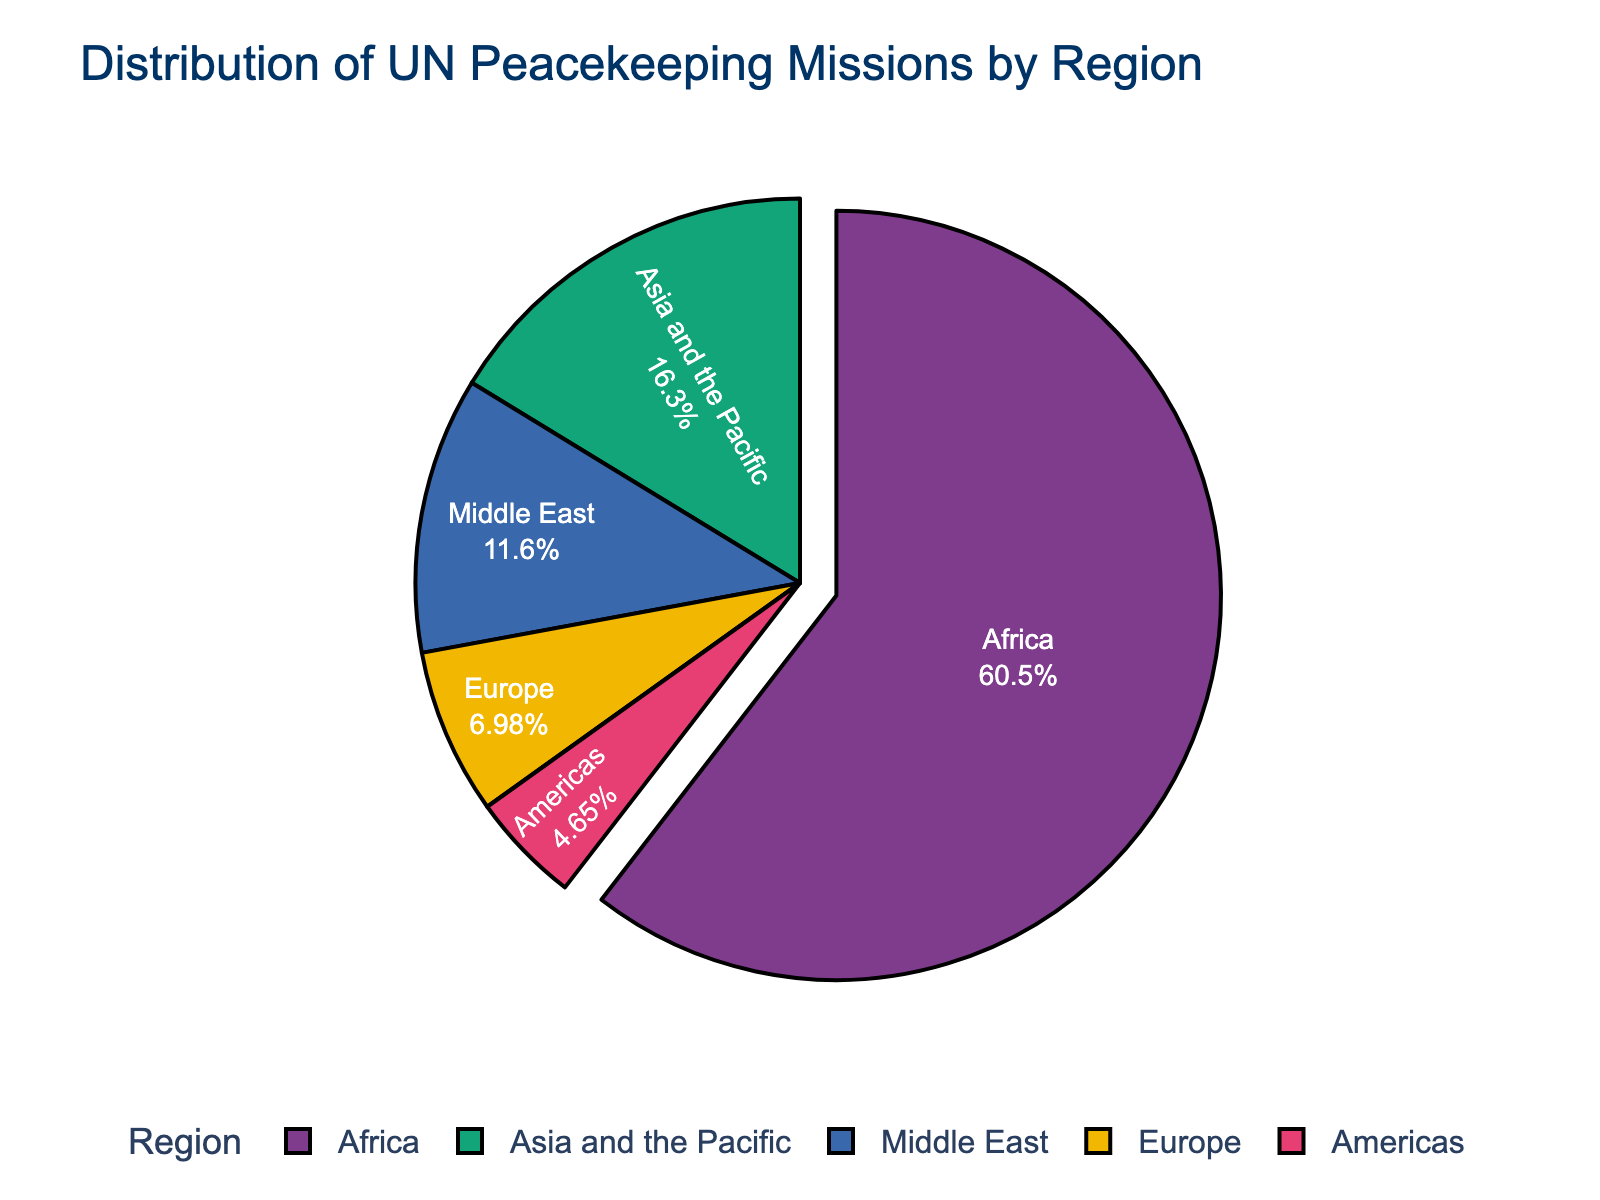Which region has the highest number of UN peacekeeping missions? Based on the largest portion of the pie chart, we can see that Africa has the highest number of missions.
Answer: Africa Which region has the fewest UN peacekeeping missions? The smallest segment of the pie chart is for the Americas, indicating it has the fewest missions.
Answer: Americas What percentage of UN peacekeeping missions are in Africa? Looking at the segment labeled "Africa", we see the percentage is marked inside the segment.
Answer: 55.3% How many more missions are there in Africa compared to Europe? Africa has 26 missions and Europe has 3, the difference is calculated as 26 - 3.
Answer: 23 Are there more missions in the Middle East or in Asia and the Pacific? Comparing the sizes of the segments for the Middle East and Asia and the Pacific, we see Asia and the Pacific has more missions (7 vs. 5).
Answer: Asia and the Pacific Which regions combined account for more than half of the UN peacekeeping missions? Adding the missions from Africa (26) and any other region whose combined total results in more than half: Africa (26) + Asia and the Pacific (7) = 33 (which is more than half of 43, the total number of missions).
Answer: Africa and Asia and the Pacific What is the total number of UN peacekeeping missions in regions outside Africa? Adding the missions for Asia and the Pacific (7), Europe (3), Middle East (5), and Americas (2) results in 17.
Answer: 17 If each region's mission percentage correlates directly to the geographic size, which region would be the largest? Since Africa has the highest percentage of missions (55.3%), it would be the largest region if mission distribution correlates directly with geographic size.
Answer: Africa What is the second-largest region by the number of missions and what percentage of the total does it represent? The second-largest region would be Asia and the Pacific with 7 missions. The percentage can be seen on the pie chart segment or calculated as (7/43) * 100.
Answer: Asia and the Pacific, 16.3% If the Middle East and the Americas were combined into a single region, what would be their total percentage of missions? Adding the missions from the Middle East (5) and the Americas (2), we get 7 missions. The percentage is (7/43) * 100.
Answer: 16.3% 